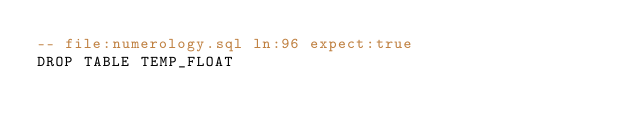<code> <loc_0><loc_0><loc_500><loc_500><_SQL_>-- file:numerology.sql ln:96 expect:true
DROP TABLE TEMP_FLOAT
</code> 